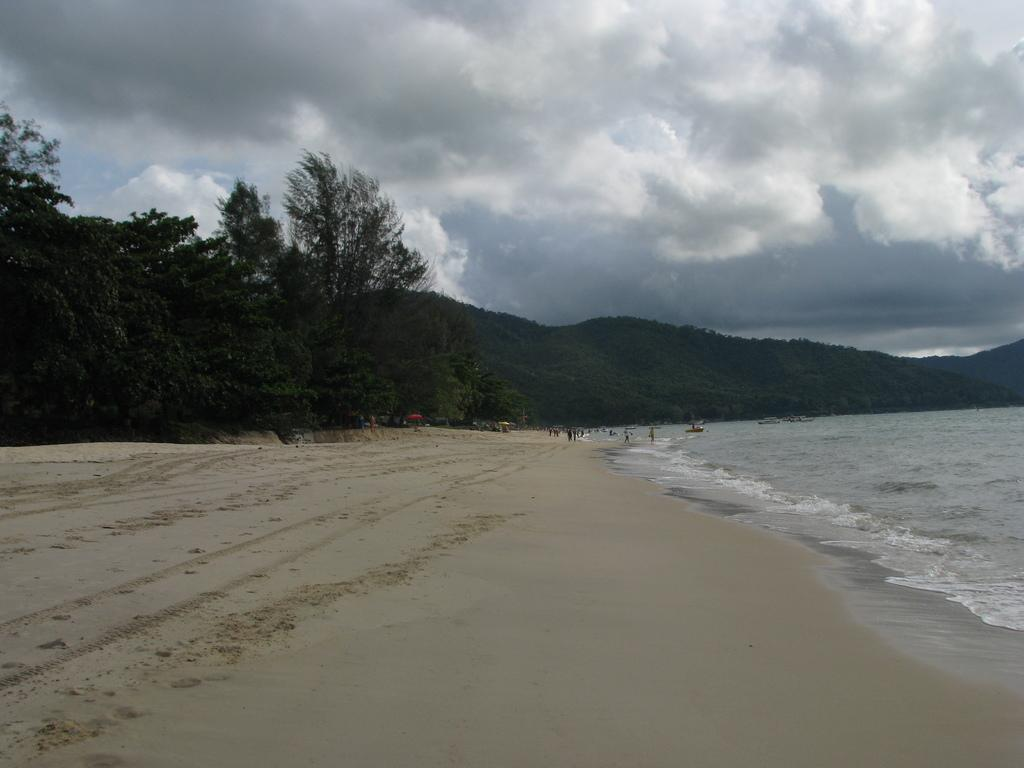What type of location is depicted in the front of the image? There is a beach in the front of the image. What are the people in the image doing? People are walking in the back of the image. What can be seen in the distance behind the beach? There are hills in the background of the image. What type of vegetation is present near the hills? Trees are present in front of the hills. What is visible in the sky in the image? The sky is visible in the background of the image, and clouds are present in the sky. What type of milk is being served in the image? There is no milk present in the image; it features a beach, people walking, hills, trees, and a sky with clouds. How many nails can be seen holding the town together in the image? There is no town or nails present in the image. 